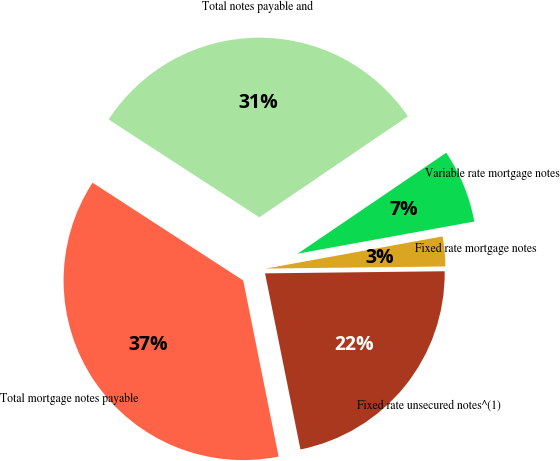Convert chart to OTSL. <chart><loc_0><loc_0><loc_500><loc_500><pie_chart><fcel>Fixed rate unsecured notes^(1)<fcel>Fixed rate mortgage notes<fcel>Variable rate mortgage notes<fcel>Total notes payable and<fcel>Total mortgage notes payable<nl><fcel>22.03%<fcel>2.68%<fcel>6.63%<fcel>31.34%<fcel>37.32%<nl></chart> 